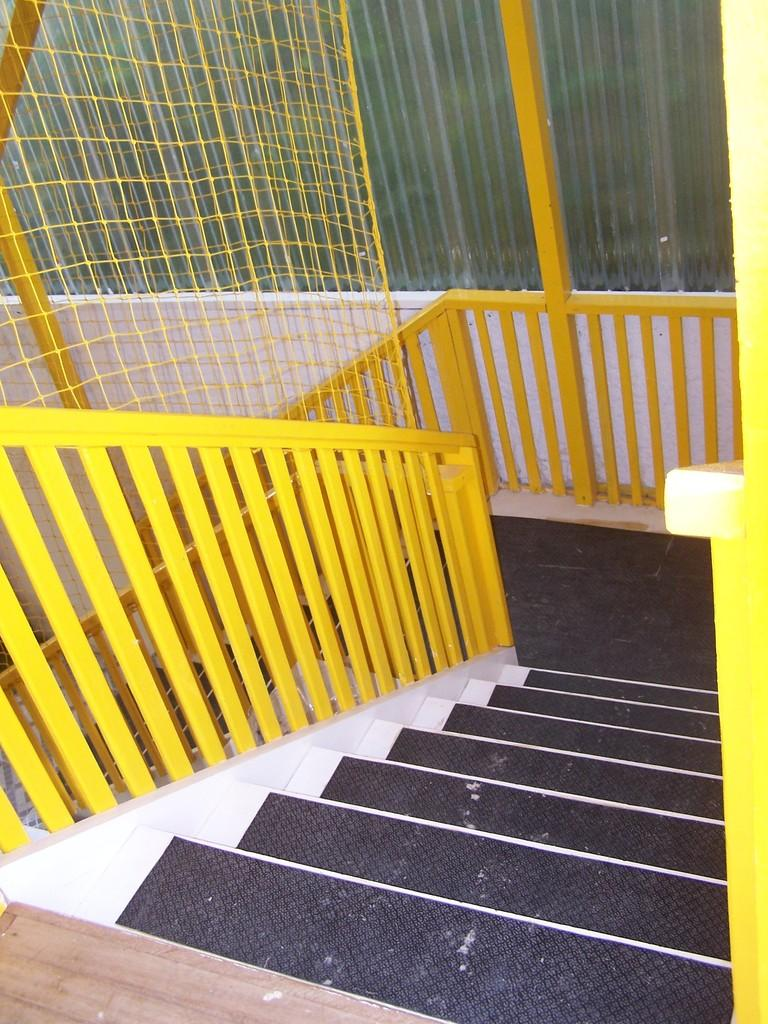What type of structure can be seen in the image? There is a railing in the image. What can be seen in the background of the image? There is a fence, a glass object, and another object visible in the background. Are there any architectural features in the image? Yes, there are steps at the bottom of the image. What type of plough is being used to design the fence in the image? There is no plough present in the image, nor is there any indication of a design process for the fence. 